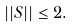<formula> <loc_0><loc_0><loc_500><loc_500>| | S | | \leq 2 .</formula> 